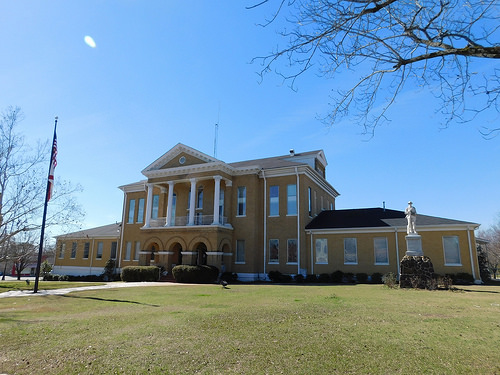<image>
Is there a flag in front of the house? Yes. The flag is positioned in front of the house, appearing closer to the camera viewpoint. 